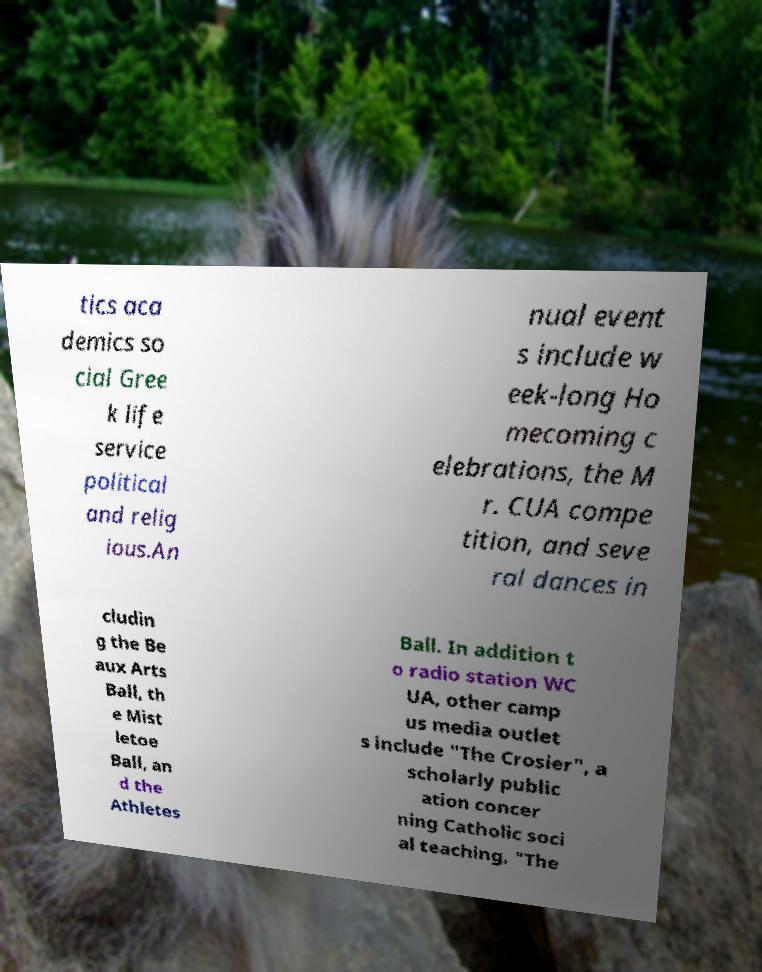Could you extract and type out the text from this image? tics aca demics so cial Gree k life service political and relig ious.An nual event s include w eek-long Ho mecoming c elebrations, the M r. CUA compe tition, and seve ral dances in cludin g the Be aux Arts Ball, th e Mist letoe Ball, an d the Athletes Ball. In addition t o radio station WC UA, other camp us media outlet s include "The Crosier", a scholarly public ation concer ning Catholic soci al teaching, "The 